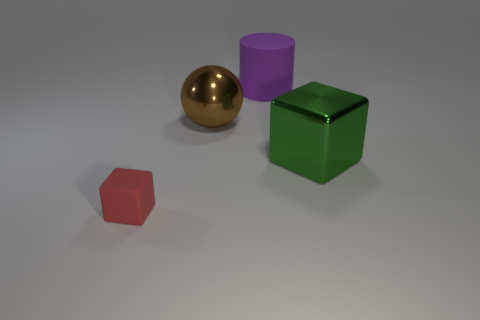Add 3 purple matte objects. How many objects exist? 7 Subtract all cylinders. How many objects are left? 3 Add 2 rubber blocks. How many rubber blocks exist? 3 Subtract 0 red balls. How many objects are left? 4 Subtract all large shiny objects. Subtract all big blocks. How many objects are left? 1 Add 3 matte things. How many matte things are left? 5 